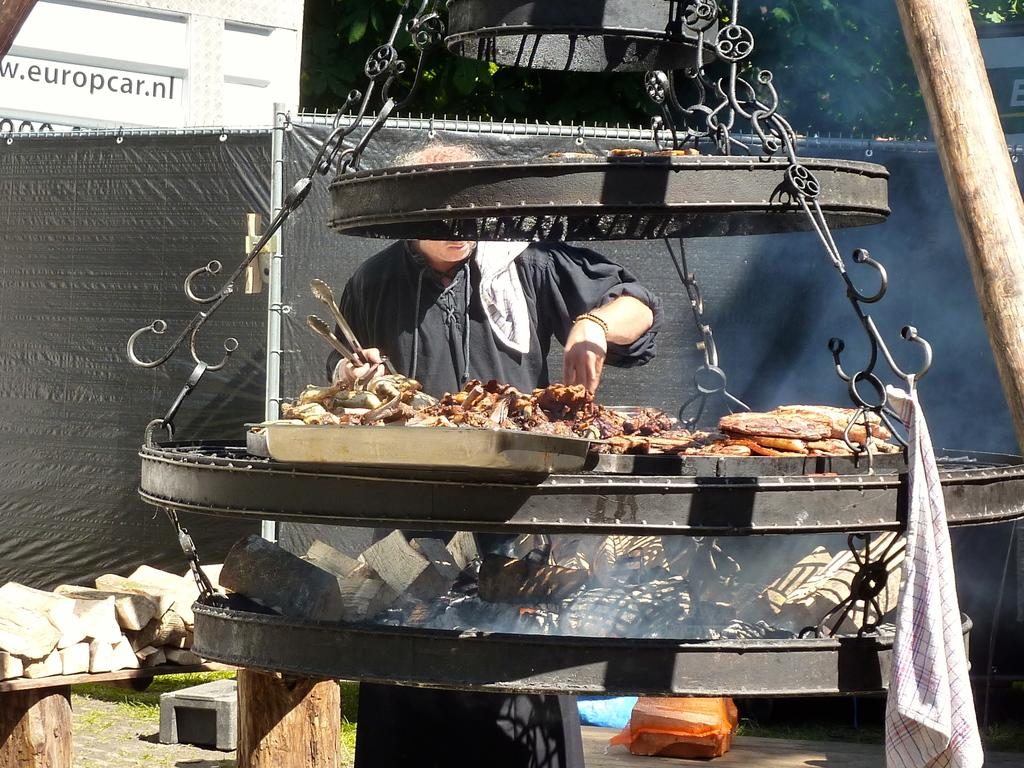What is the person in the image doing? The person is preparing food. What can be seen in the image that might be used for cooking? There is a furnace in the image. What is hanging in the image? A cloth is hanging in the image. Can you describe the cloth in the background of the image? There is a black cloth on the fence in the background of the image. What type of books can be seen on the person's head in the image? There are no books visible in the image; the person is preparing food. 